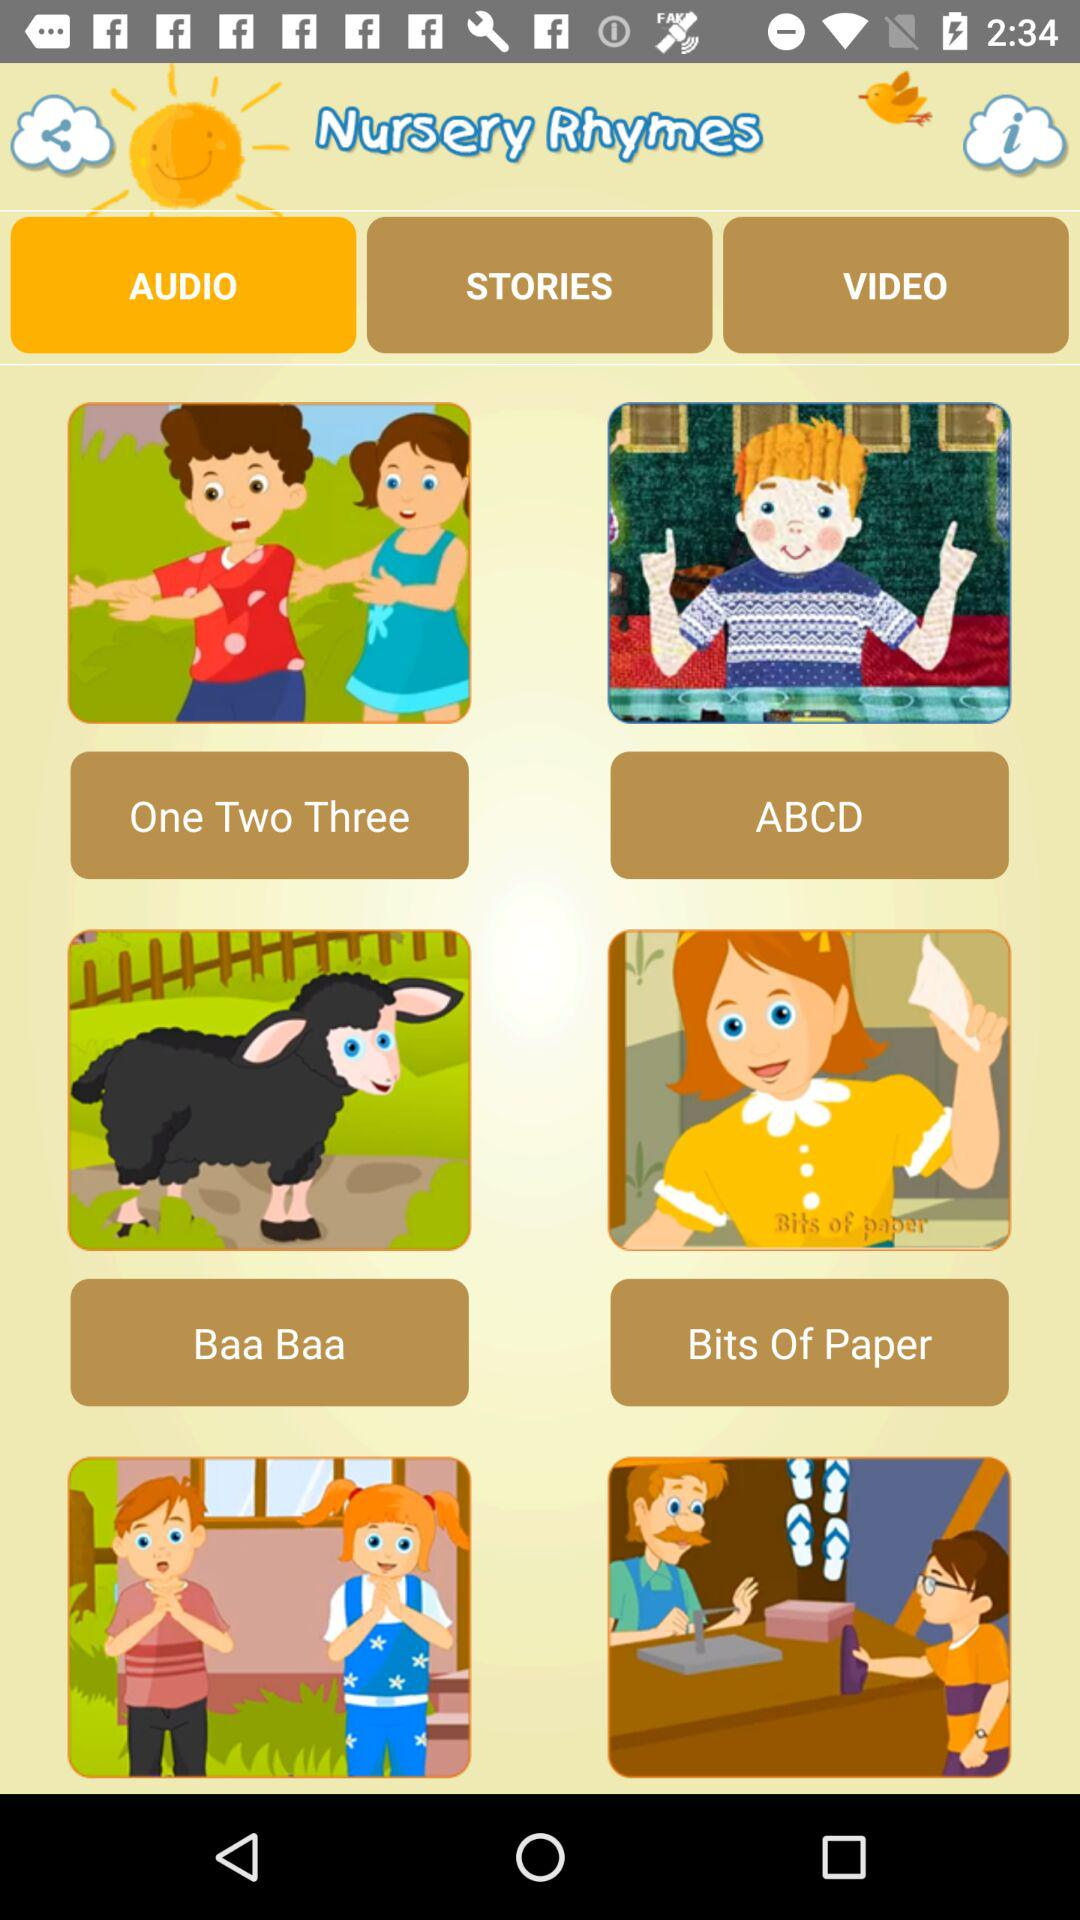What is the name of the application? The name of the application is "Nursery Rhymes". 